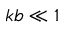<formula> <loc_0><loc_0><loc_500><loc_500>k b \ll 1</formula> 